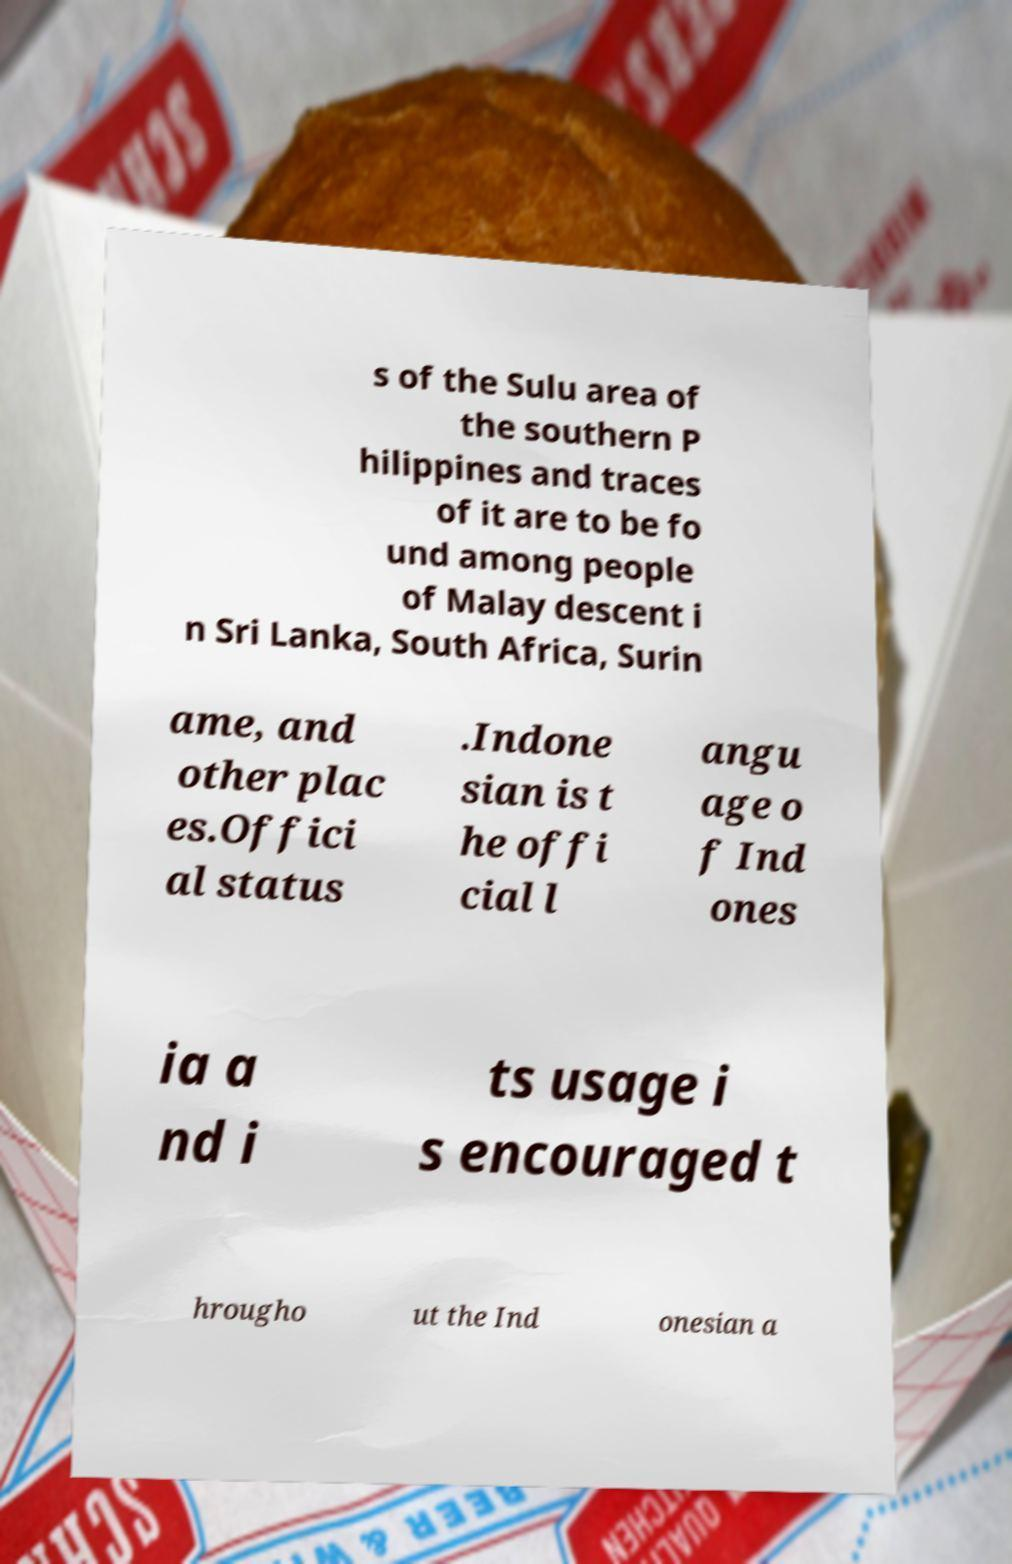Please read and relay the text visible in this image. What does it say? s of the Sulu area of the southern P hilippines and traces of it are to be fo und among people of Malay descent i n Sri Lanka, South Africa, Surin ame, and other plac es.Offici al status .Indone sian is t he offi cial l angu age o f Ind ones ia a nd i ts usage i s encouraged t hrougho ut the Ind onesian a 